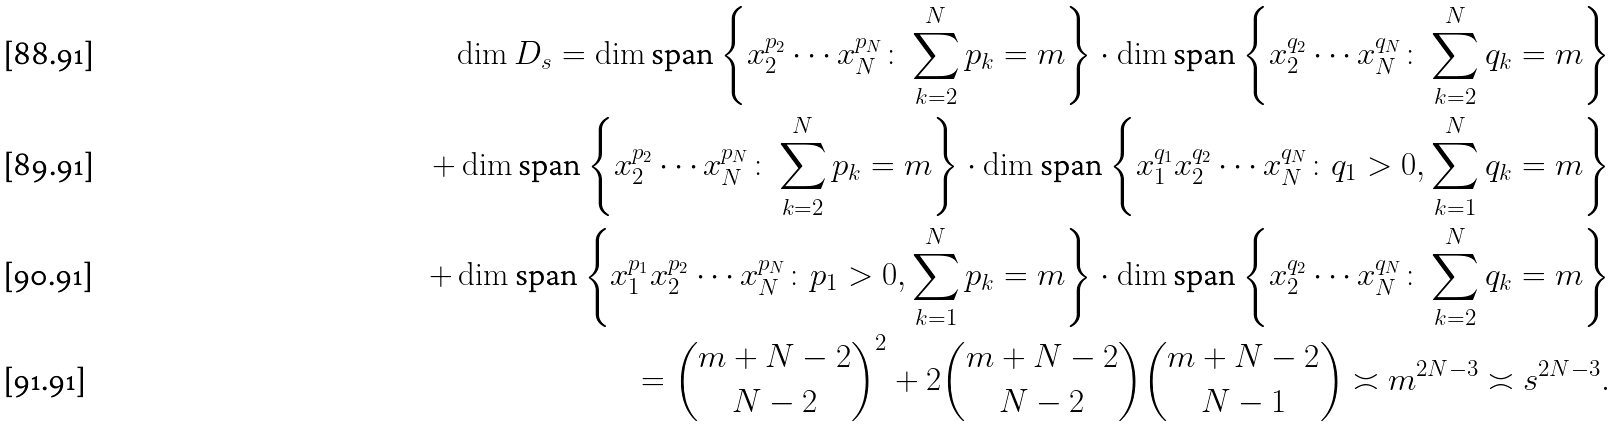<formula> <loc_0><loc_0><loc_500><loc_500>\dim D _ { s } = \dim \text {span} \left \{ x _ { 2 } ^ { p _ { 2 } } \cdots x _ { N } ^ { p _ { N } } \colon \sum _ { k = 2 } ^ { N } p _ { k } = m \right \} \cdot \dim \text {span} \left \{ x _ { 2 } ^ { q _ { 2 } } \cdots x _ { N } ^ { q _ { N } } \colon \sum _ { k = 2 } ^ { N } q _ { k } = m \right \} \\ + \dim \text {span} \left \{ x _ { 2 } ^ { p _ { 2 } } \cdots x _ { N } ^ { p _ { N } } \colon \sum _ { k = 2 } ^ { N } p _ { k } = m \right \} \cdot \dim \text {span} \left \{ x _ { 1 } ^ { q _ { 1 } } x _ { 2 } ^ { q _ { 2 } } \cdots x _ { N } ^ { q _ { N } } \colon q _ { 1 } > 0 , \sum _ { k = 1 } ^ { N } q _ { k } = m \right \} \\ + \dim \text {span} \left \{ x _ { 1 } ^ { p _ { 1 } } x _ { 2 } ^ { p _ { 2 } } \cdots x _ { N } ^ { p _ { N } } \colon p _ { 1 } > 0 , \sum _ { k = 1 } ^ { N } p _ { k } = m \right \} \cdot \dim \text {span} \left \{ x _ { 2 } ^ { q _ { 2 } } \cdots x _ { N } ^ { q _ { N } } \colon \sum _ { k = 2 } ^ { N } q _ { k } = m \right \} \\ = \binom { m + N - 2 } { N - 2 } ^ { 2 } + 2 \binom { m + N - 2 } { N - 2 } \binom { m + N - 2 } { N - 1 } \asymp m ^ { 2 N - 3 } \asymp s ^ { 2 N - 3 } .</formula> 